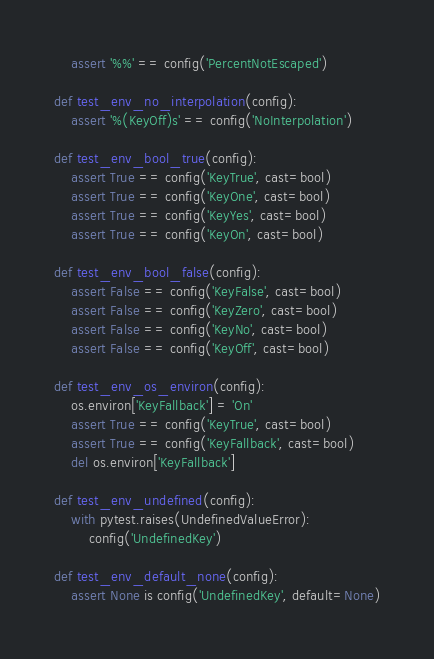<code> <loc_0><loc_0><loc_500><loc_500><_Python_>    assert '%%' == config('PercentNotEscaped')

def test_env_no_interpolation(config):
    assert '%(KeyOff)s' == config('NoInterpolation')

def test_env_bool_true(config):
    assert True == config('KeyTrue', cast=bool)
    assert True == config('KeyOne', cast=bool)
    assert True == config('KeyYes', cast=bool)
    assert True == config('KeyOn', cast=bool)

def test_env_bool_false(config):
    assert False == config('KeyFalse', cast=bool)
    assert False == config('KeyZero', cast=bool)
    assert False == config('KeyNo', cast=bool)
    assert False == config('KeyOff', cast=bool)

def test_env_os_environ(config):
    os.environ['KeyFallback'] = 'On'
    assert True == config('KeyTrue', cast=bool)
    assert True == config('KeyFallback', cast=bool)
    del os.environ['KeyFallback']

def test_env_undefined(config):
    with pytest.raises(UndefinedValueError):
        config('UndefinedKey')

def test_env_default_none(config):
    assert None is config('UndefinedKey', default=None)
</code> 